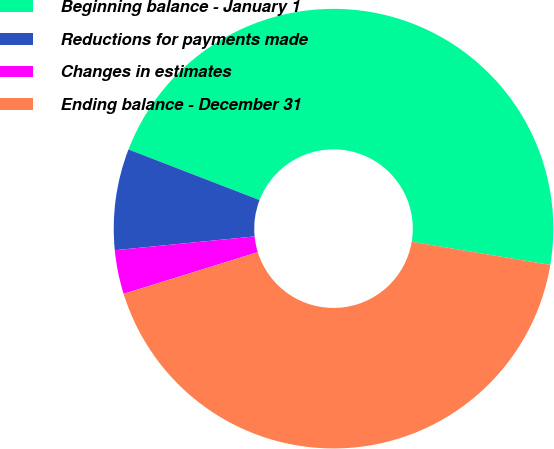Convert chart to OTSL. <chart><loc_0><loc_0><loc_500><loc_500><pie_chart><fcel>Beginning balance - January 1<fcel>Reductions for payments made<fcel>Changes in estimates<fcel>Ending balance - December 31<nl><fcel>46.77%<fcel>7.43%<fcel>3.23%<fcel>42.57%<nl></chart> 